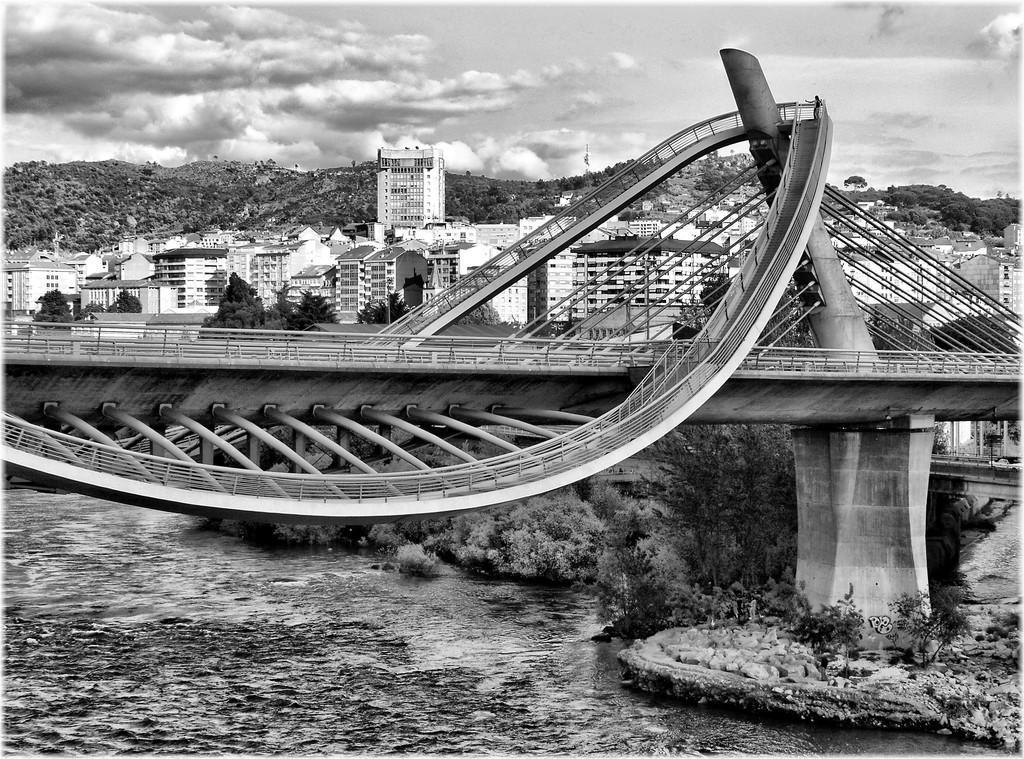How would you summarize this image in a sentence or two? This image is taken outdoors. This image is a black and white image. At the top of the image there is the sky with clouds. In the background there are a few hills, trees and plants. There are many buildings and houses. There are few trees and plants. In the middle of the image there is a bridge. At the bottom of the image there is a lake with water. 